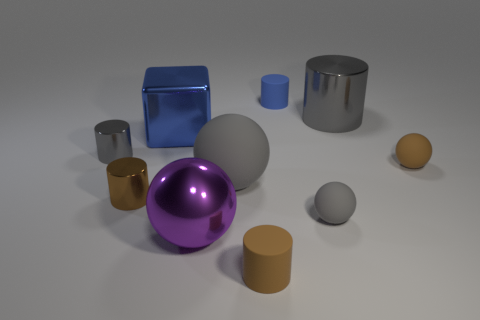What number of blocks are large blue shiny things or small objects?
Offer a terse response. 1. The large matte sphere is what color?
Provide a short and direct response. Gray. Are there more green matte spheres than big shiny cubes?
Give a very brief answer. No. What number of things are either things in front of the big gray metal cylinder or matte cylinders?
Your answer should be very brief. 9. Are the brown ball and the cube made of the same material?
Ensure brevity in your answer.  No. There is another gray thing that is the same shape as the small gray shiny object; what is its size?
Offer a terse response. Large. There is a brown thing that is on the left side of the big blue shiny object; does it have the same shape as the object in front of the large shiny sphere?
Keep it short and to the point. Yes. Is the size of the brown shiny object the same as the blue object in front of the big gray metallic thing?
Your answer should be compact. No. How many other things are there of the same material as the large gray cylinder?
Provide a short and direct response. 4. Is there anything else that has the same shape as the large blue thing?
Provide a succinct answer. No. 